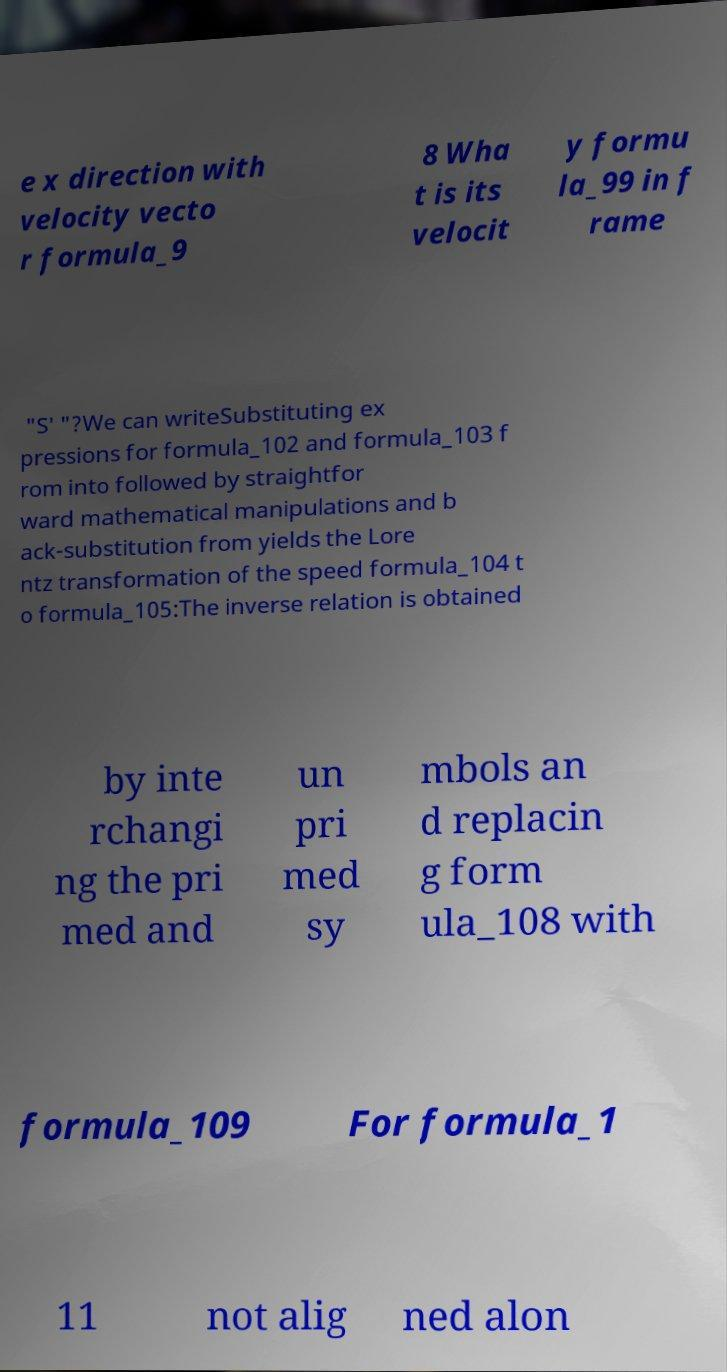Can you read and provide the text displayed in the image?This photo seems to have some interesting text. Can you extract and type it out for me? e x direction with velocity vecto r formula_9 8 Wha t is its velocit y formu la_99 in f rame "S′ "?We can writeSubstituting ex pressions for formula_102 and formula_103 f rom into followed by straightfor ward mathematical manipulations and b ack-substitution from yields the Lore ntz transformation of the speed formula_104 t o formula_105:The inverse relation is obtained by inte rchangi ng the pri med and un pri med sy mbols an d replacin g form ula_108 with formula_109 For formula_1 11 not alig ned alon 